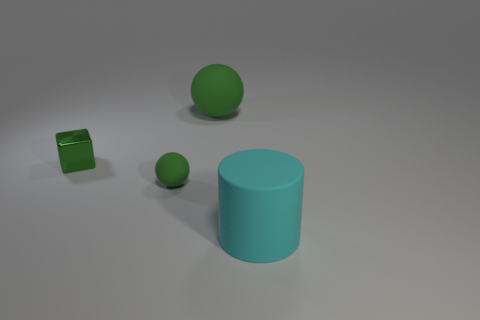What shape is the matte object that is both behind the large cyan cylinder and right of the small green sphere? The matte object that is positioned behind the large cyan cylinder and to the right of the small green sphere is a cube. 